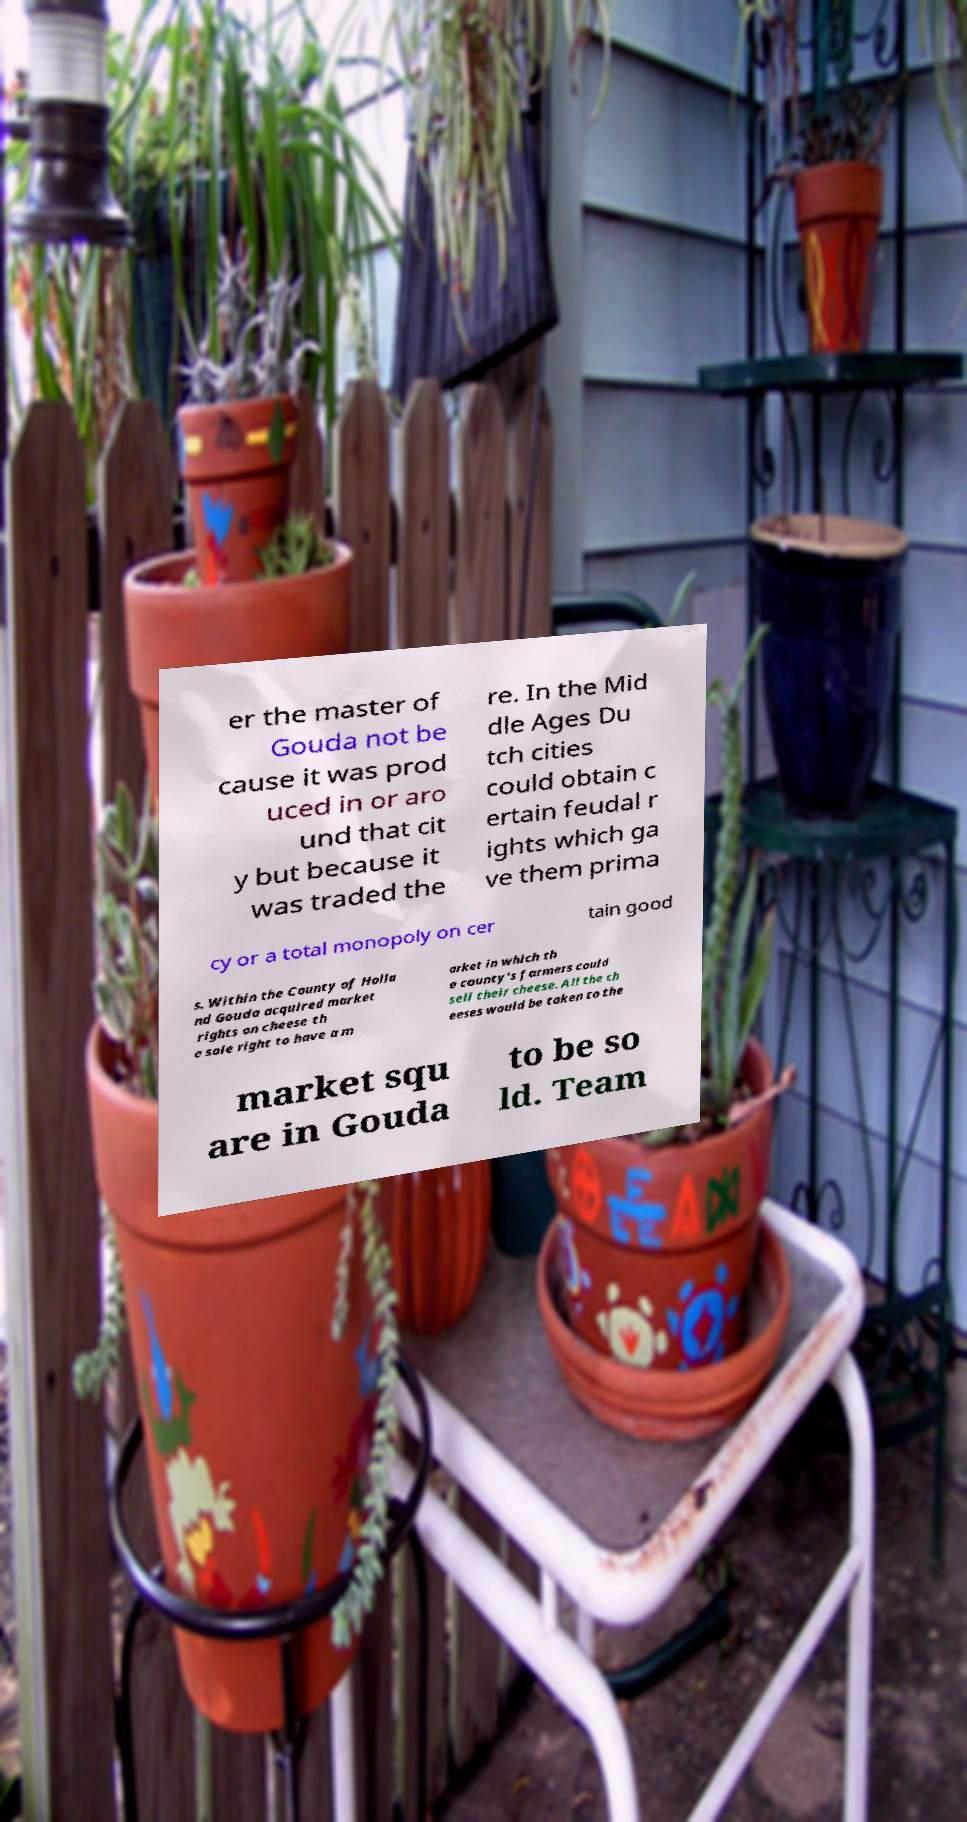Please identify and transcribe the text found in this image. er the master of Gouda not be cause it was prod uced in or aro und that cit y but because it was traded the re. In the Mid dle Ages Du tch cities could obtain c ertain feudal r ights which ga ve them prima cy or a total monopoly on cer tain good s. Within the County of Holla nd Gouda acquired market rights on cheese th e sole right to have a m arket in which th e county's farmers could sell their cheese. All the ch eeses would be taken to the market squ are in Gouda to be so ld. Team 